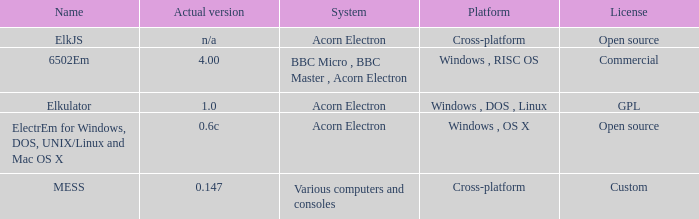What is the system called that is named ELKJS? Acorn Electron. 